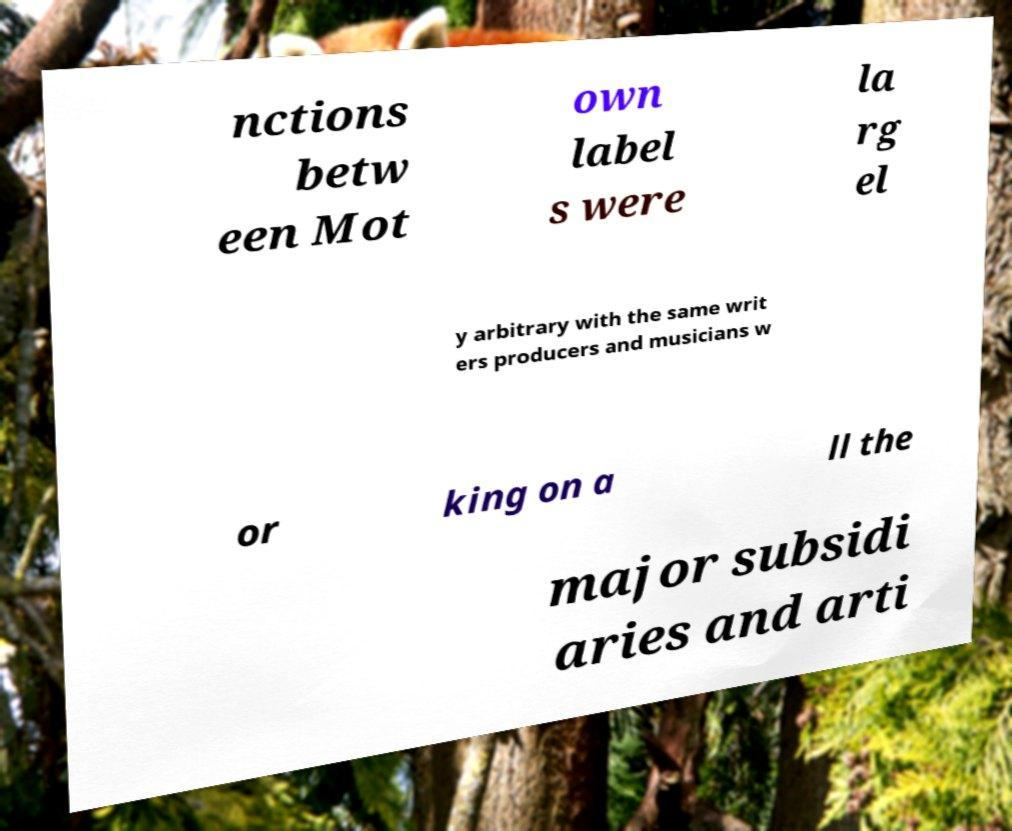Could you extract and type out the text from this image? nctions betw een Mot own label s were la rg el y arbitrary with the same writ ers producers and musicians w or king on a ll the major subsidi aries and arti 